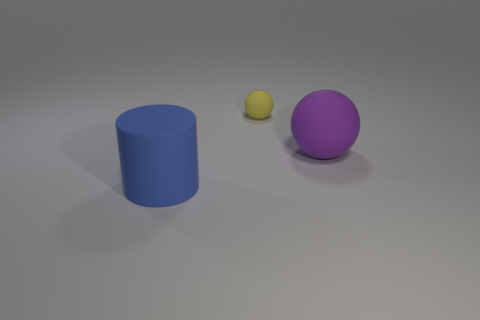What textures are visible on the objects? The cylinder and sphere exhibit a smooth and slightly reflective surface suggesting a plastic or rubber-like material. The yellow ball has a rubbery texture as well but with a less reflective surface, making it appear matte in comparison to the other objects. 